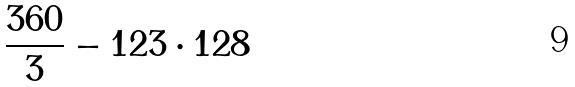<formula> <loc_0><loc_0><loc_500><loc_500>\frac { 3 6 0 } { 3 } - 1 2 3 \cdot 1 2 8</formula> 